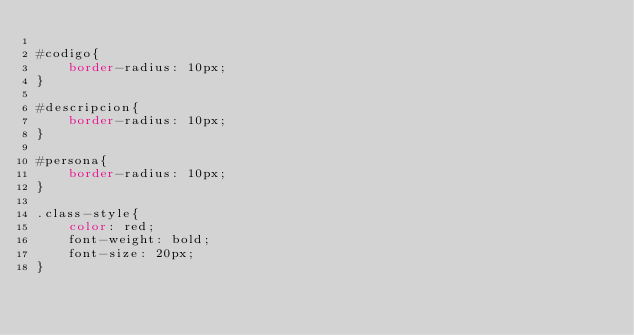Convert code to text. <code><loc_0><loc_0><loc_500><loc_500><_CSS_>
#codigo{
    border-radius: 10px;
}

#descripcion{
    border-radius: 10px;
}

#persona{
    border-radius: 10px;
}

.class-style{
    color: red;
    font-weight: bold;
    font-size: 20px;
}</code> 